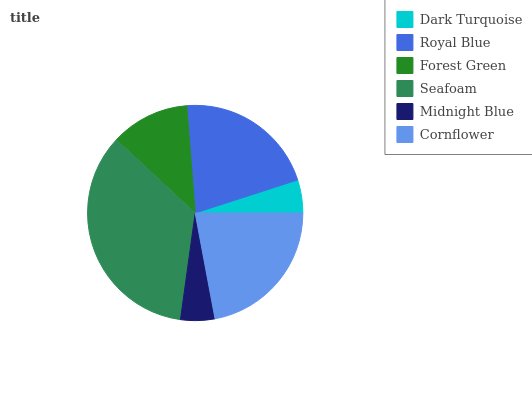Is Dark Turquoise the minimum?
Answer yes or no. Yes. Is Seafoam the maximum?
Answer yes or no. Yes. Is Royal Blue the minimum?
Answer yes or no. No. Is Royal Blue the maximum?
Answer yes or no. No. Is Royal Blue greater than Dark Turquoise?
Answer yes or no. Yes. Is Dark Turquoise less than Royal Blue?
Answer yes or no. Yes. Is Dark Turquoise greater than Royal Blue?
Answer yes or no. No. Is Royal Blue less than Dark Turquoise?
Answer yes or no. No. Is Royal Blue the high median?
Answer yes or no. Yes. Is Forest Green the low median?
Answer yes or no. Yes. Is Forest Green the high median?
Answer yes or no. No. Is Dark Turquoise the low median?
Answer yes or no. No. 